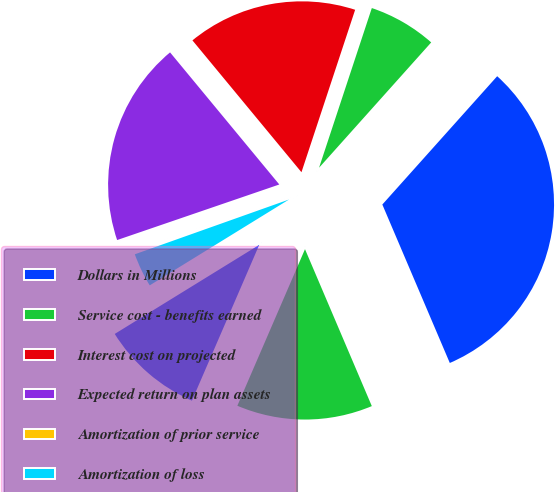Convert chart to OTSL. <chart><loc_0><loc_0><loc_500><loc_500><pie_chart><fcel>Dollars in Millions<fcel>Service cost - benefits earned<fcel>Interest cost on projected<fcel>Expected return on plan assets<fcel>Amortization of prior service<fcel>Amortization of loss<fcel>Net periodic benefit cost<fcel>Total net periodic benefit<nl><fcel>31.98%<fcel>6.54%<fcel>16.08%<fcel>19.26%<fcel>0.18%<fcel>3.36%<fcel>9.72%<fcel>12.9%<nl></chart> 